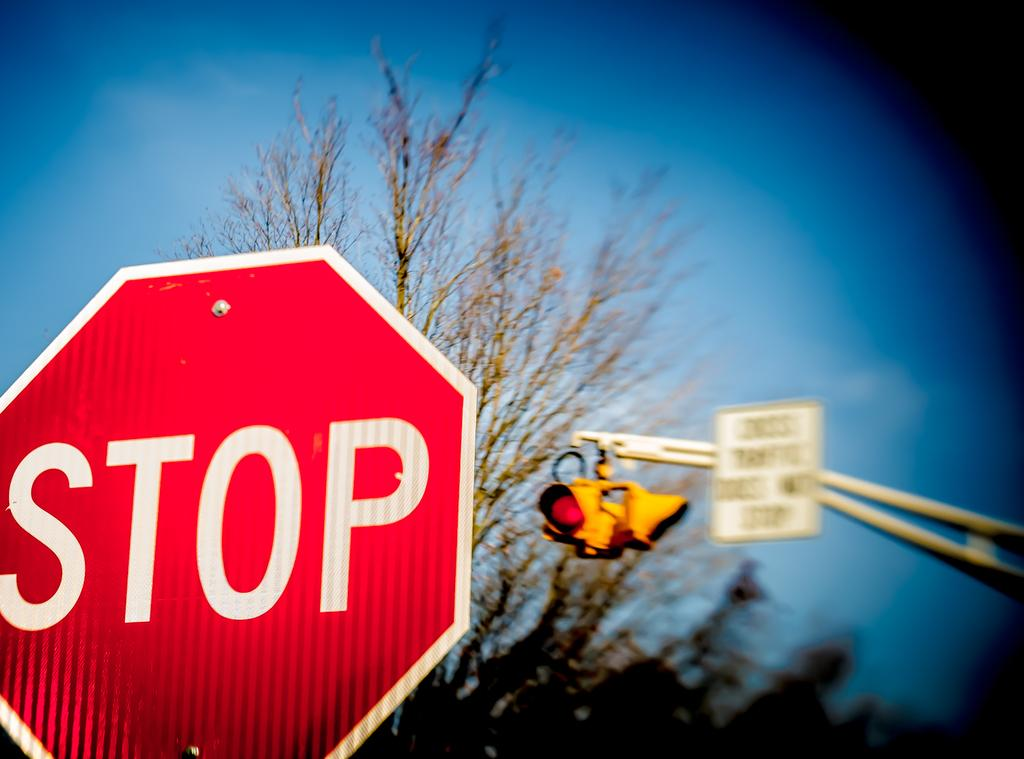<image>
Offer a succinct explanation of the picture presented. A red STOP sign infront of a traffic light 